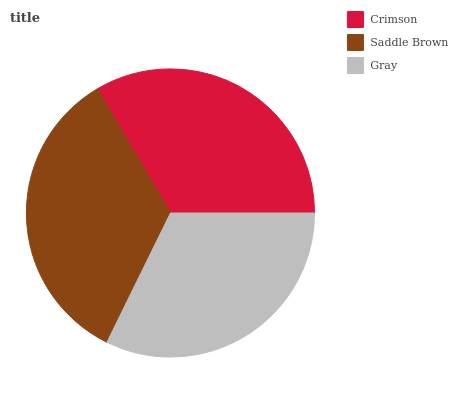Is Gray the minimum?
Answer yes or no. Yes. Is Saddle Brown the maximum?
Answer yes or no. Yes. Is Saddle Brown the minimum?
Answer yes or no. No. Is Gray the maximum?
Answer yes or no. No. Is Saddle Brown greater than Gray?
Answer yes or no. Yes. Is Gray less than Saddle Brown?
Answer yes or no. Yes. Is Gray greater than Saddle Brown?
Answer yes or no. No. Is Saddle Brown less than Gray?
Answer yes or no. No. Is Crimson the high median?
Answer yes or no. Yes. Is Crimson the low median?
Answer yes or no. Yes. Is Gray the high median?
Answer yes or no. No. Is Saddle Brown the low median?
Answer yes or no. No. 